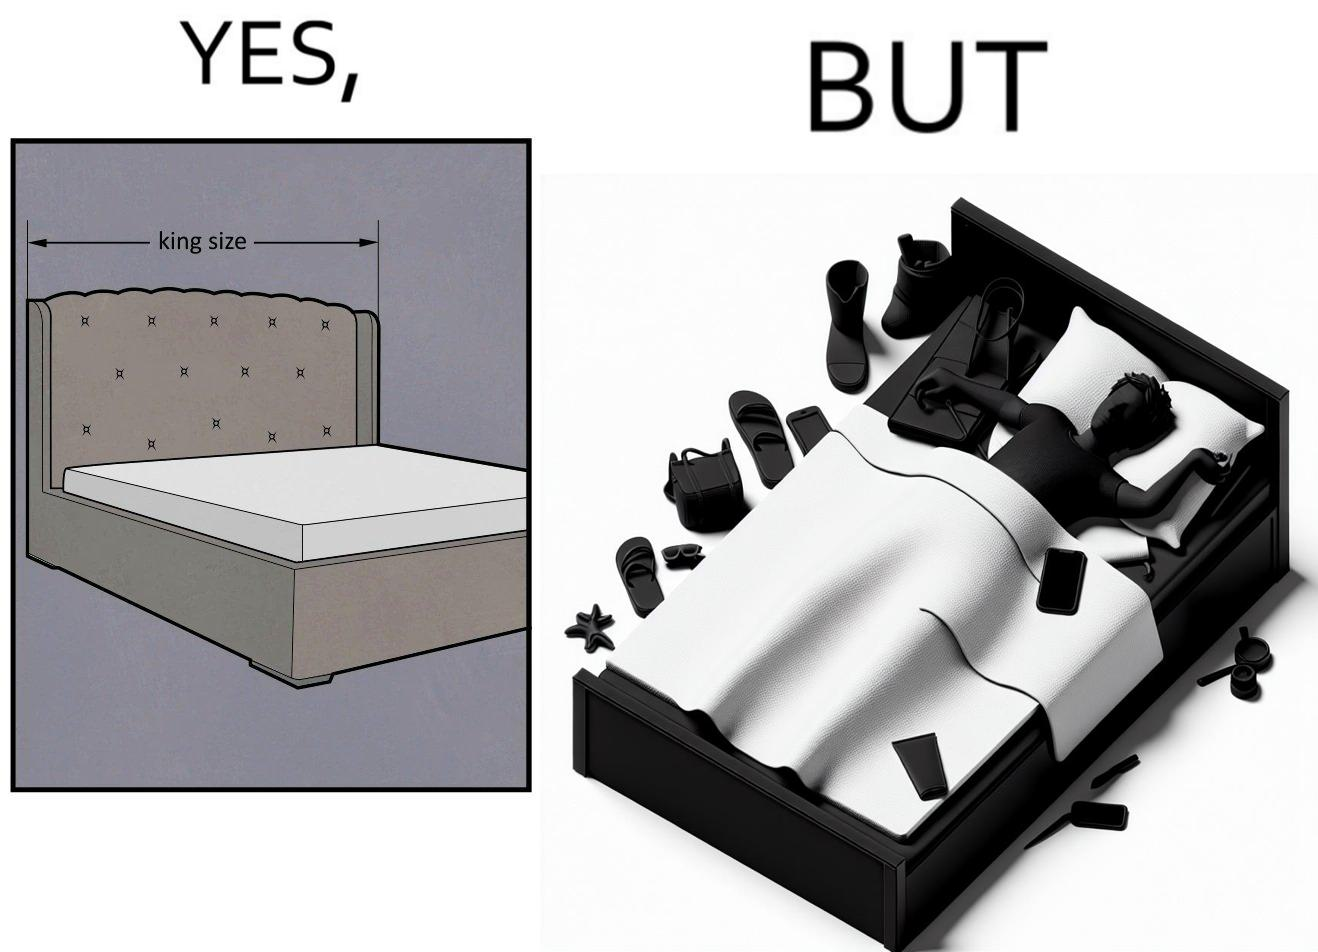What is shown in this image? Although the person has purchased a king size bed, but only less than half of the space is used by the person for sleeping. 